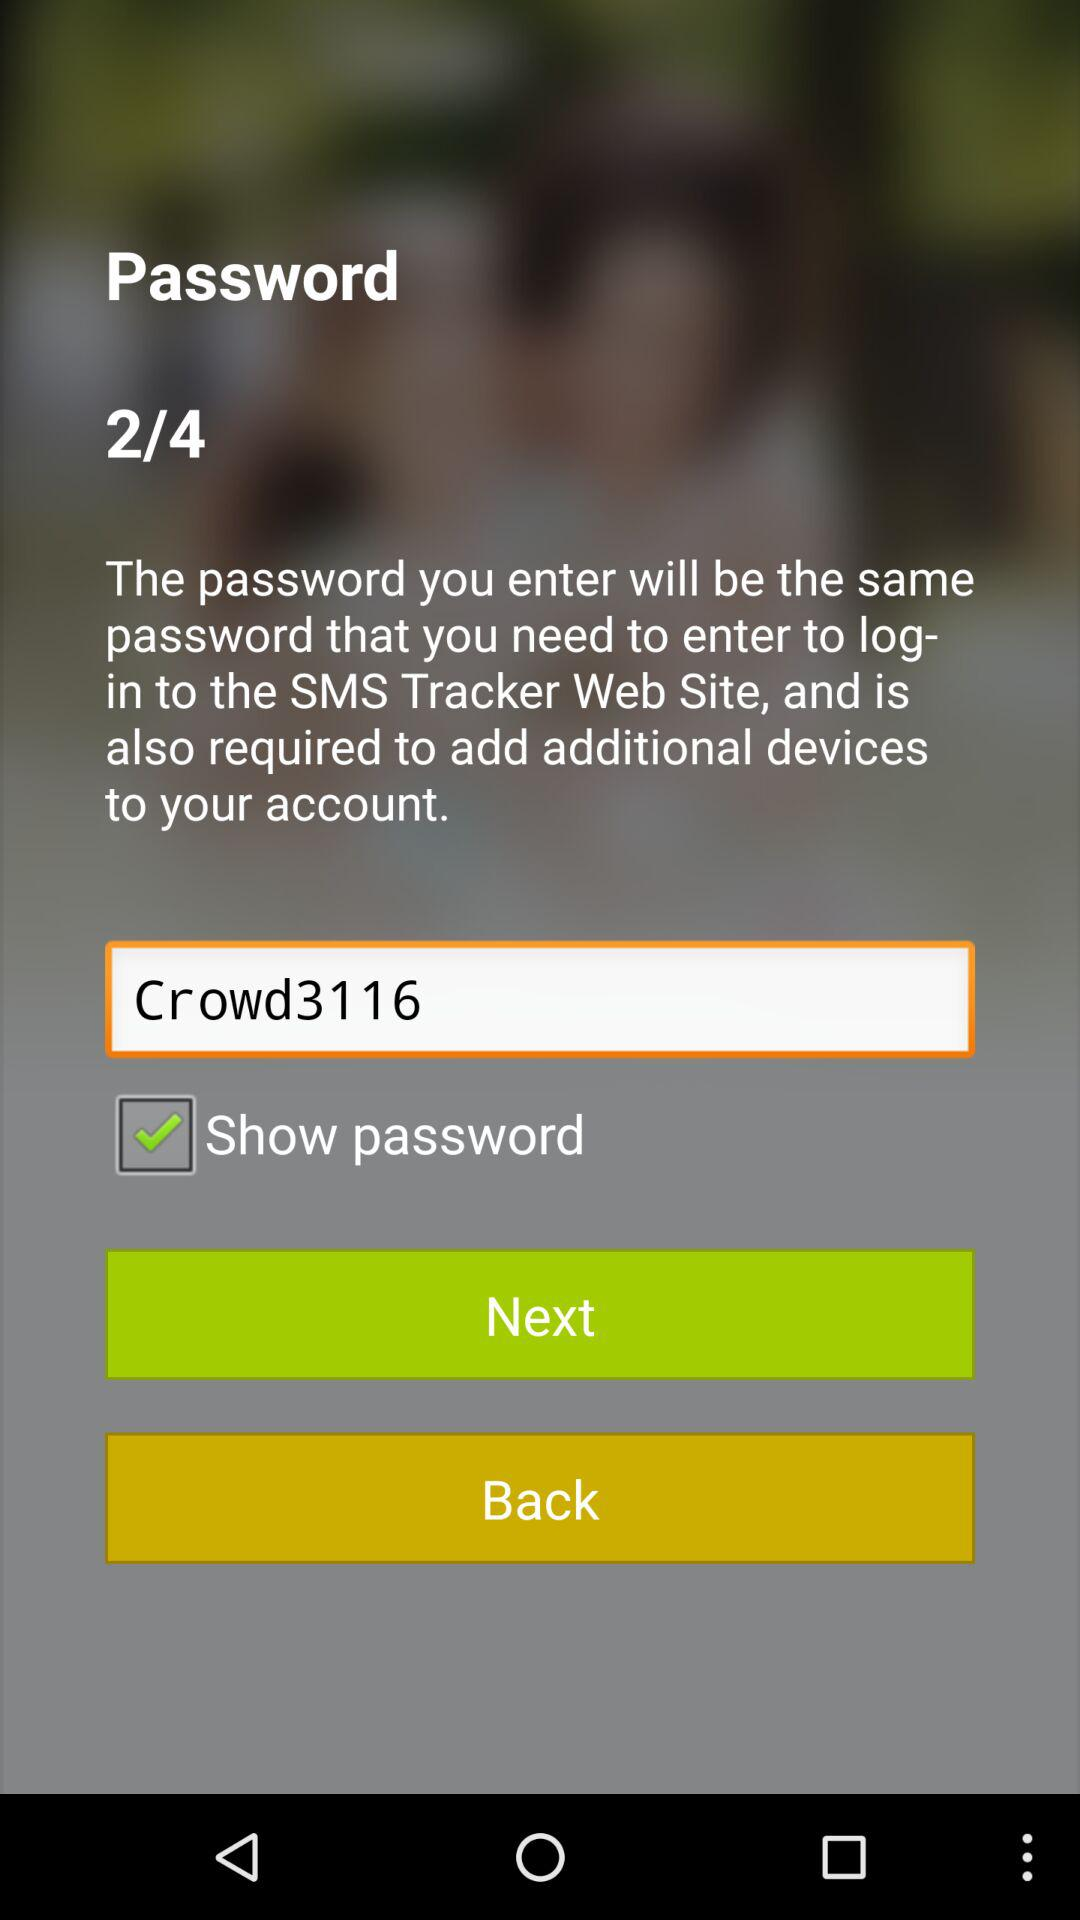How many steps are left in this process?
Answer the question using a single word or phrase. 2 